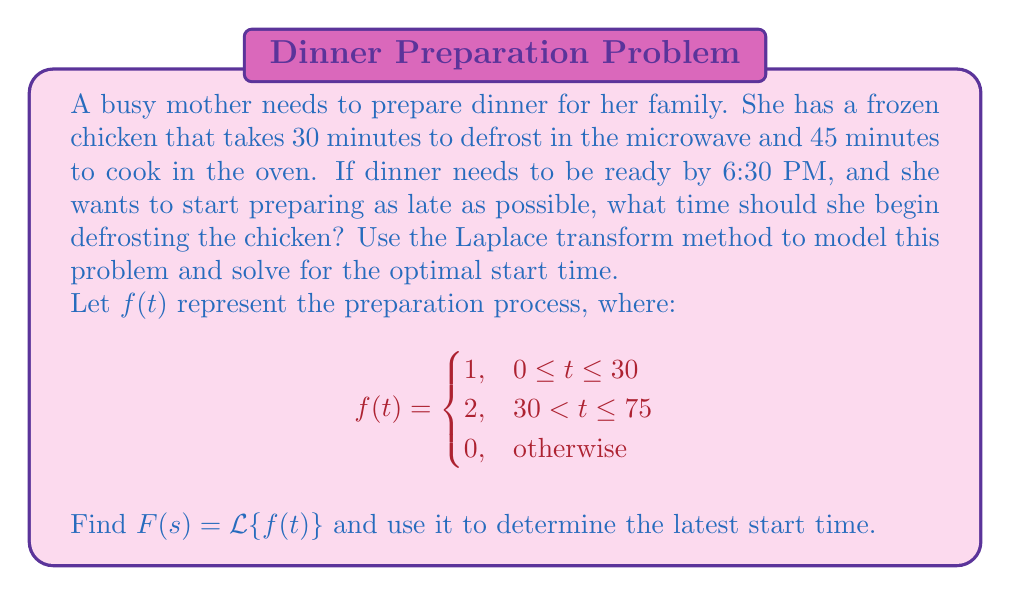Provide a solution to this math problem. To solve this problem using the Laplace transform method, we'll follow these steps:

1) First, let's define our function $f(t)$ in the Laplace domain:

   $$F(s) = \mathcal{L}\{f(t)\} = \int_0^{30} e^{-st} dt + 2\int_{30}^{75} e^{-st} dt$$

2) Evaluate the integrals:

   $$F(s) = \left[-\frac{1}{s}e^{-st}\right]_0^{30} + 2\left[-\frac{1}{s}e^{-st}\right]_{30}^{75}$$
   
   $$F(s) = \frac{1}{s}(1-e^{-30s}) + \frac{2}{s}(e^{-30s}-e^{-75s})$$

3) To find the total preparation time, we need to calculate the first moment of $f(t)$:

   $$-\frac{d}{ds}F(s)|_{s=0} = \int_0^{\infty} tf(t) dt$$

4) Differentiate $F(s)$:

   $$-\frac{d}{ds}F(s) = \frac{1}{s^2}(1-e^{-30s}) + \frac{30}{s}e^{-30s} + \frac{2}{s^2}(e^{-30s}-e^{-75s}) + \frac{60}{s}e^{-30s} - \frac{150}{s}e^{-75s}$$

5) Evaluate at $s=0$:

   $$-\frac{d}{ds}F(s)|_{s=0} = 30 + 2(75-30) = 120$$

6) The total preparation time is 120 minutes or 2 hours.

7) If dinner needs to be ready by 6:30 PM, the latest start time would be 2 hours before that, which is 4:30 PM.
Answer: The busy mother should begin defrosting the chicken at 4:30 PM to have dinner ready by 6:30 PM. 